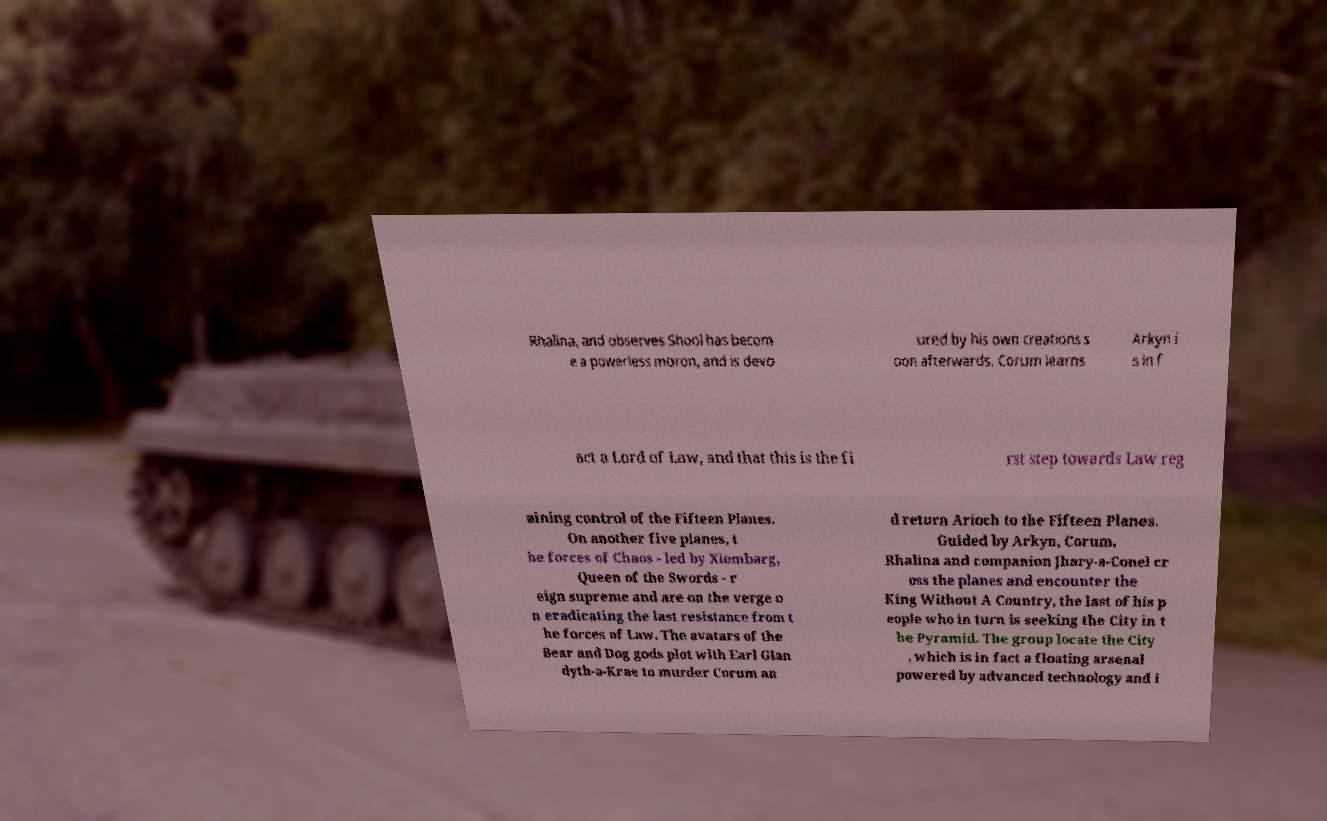I need the written content from this picture converted into text. Can you do that? Rhalina, and observes Shool has becom e a powerless moron, and is devo ured by his own creations s oon afterwards. Corum learns Arkyn i s in f act a Lord of Law, and that this is the fi rst step towards Law reg aining control of the Fifteen Planes. On another five planes, t he forces of Chaos - led by Xiombarg, Queen of the Swords - r eign supreme and are on the verge o n eradicating the last resistance from t he forces of Law. The avatars of the Bear and Dog gods plot with Earl Glan dyth-a-Krae to murder Corum an d return Arioch to the Fifteen Planes. Guided by Arkyn, Corum, Rhalina and companion Jhary-a-Conel cr oss the planes and encounter the King Without A Country, the last of his p eople who in turn is seeking the City in t he Pyramid. The group locate the City , which is in fact a floating arsenal powered by advanced technology and i 